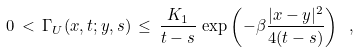<formula> <loc_0><loc_0><loc_500><loc_500>0 \, < \, \Gamma _ { U } ( x , t ; y , s ) \, \leq \, \frac { K _ { 1 } } { t - s } \, \exp \left ( - \beta \frac { | x - y | ^ { 2 } } { 4 ( t - s ) } \right ) \ ,</formula> 